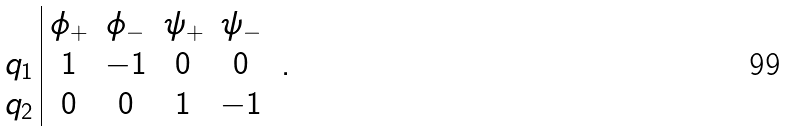<formula> <loc_0><loc_0><loc_500><loc_500>\begin{array} { c | c c c c } & \phi _ { + } & \phi _ { - } & \psi _ { + } & \psi _ { - } \\ q _ { 1 } & 1 & - 1 & 0 & 0 \\ q _ { 2 } & 0 & 0 & 1 & - 1 \end{array} \ .</formula> 